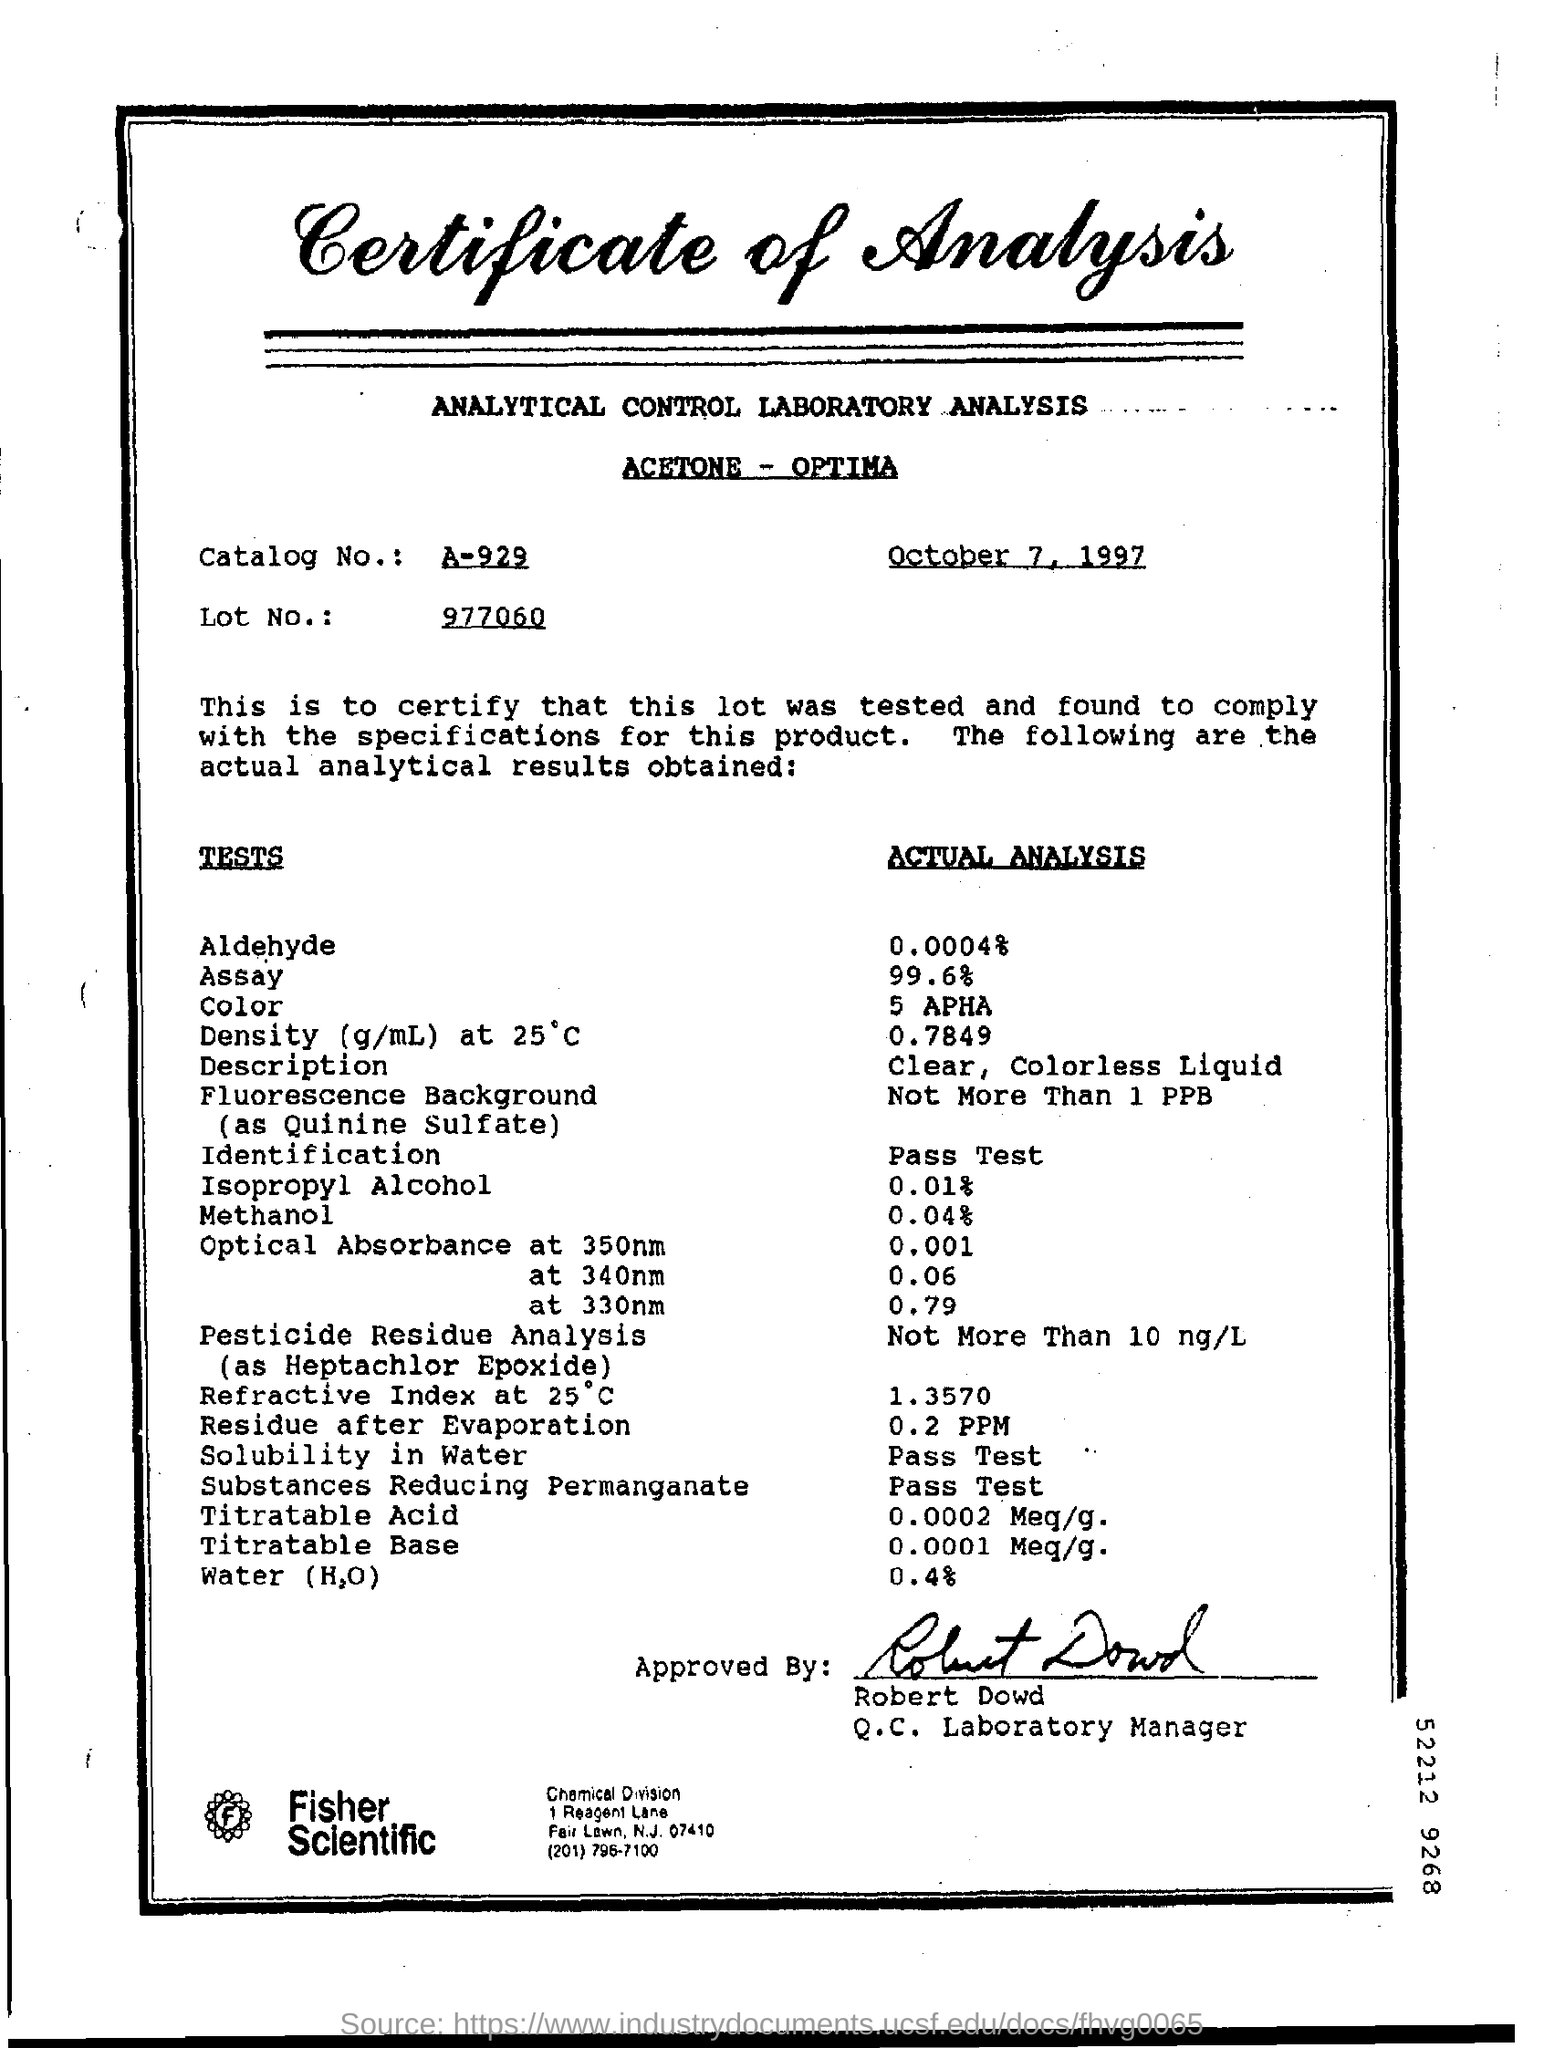Specify some key components in this picture. The lot number is 977060. The date mentioned is October 7, 1997. 